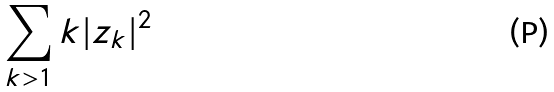Convert formula to latex. <formula><loc_0><loc_0><loc_500><loc_500>\sum _ { k > 1 } k | z _ { k } | ^ { 2 }</formula> 